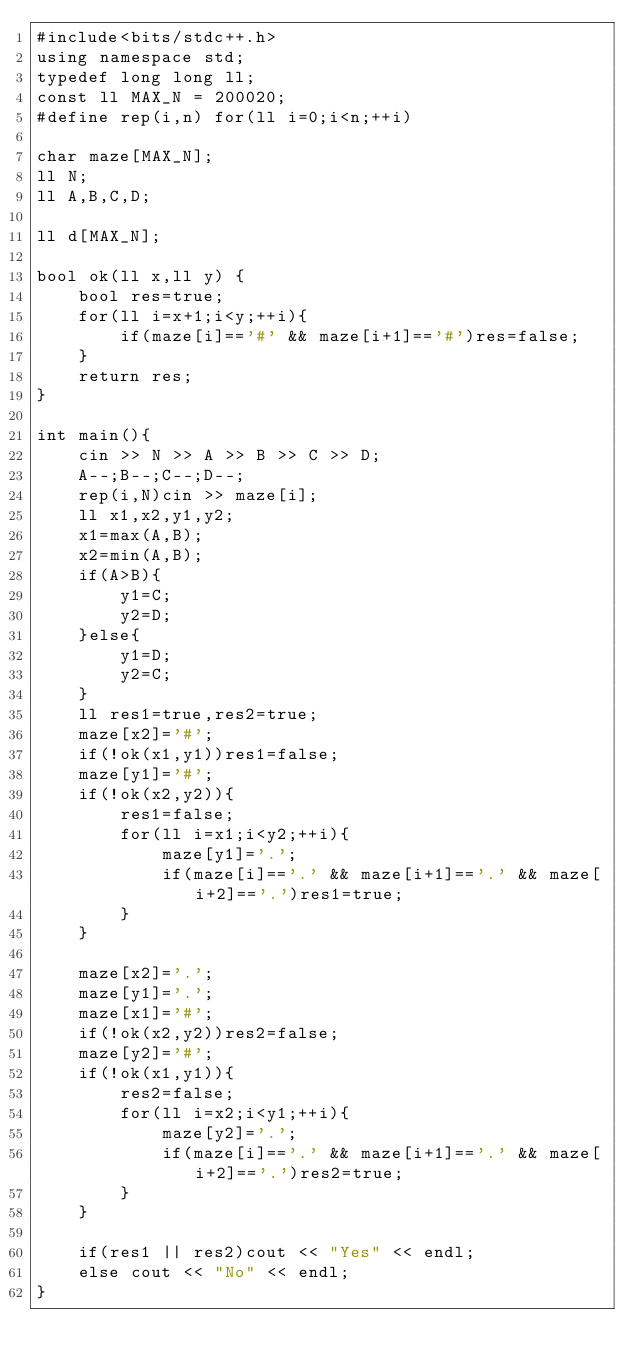<code> <loc_0><loc_0><loc_500><loc_500><_C++_>#include<bits/stdc++.h>
using namespace std;
typedef long long ll;
const ll MAX_N = 200020;
#define rep(i,n) for(ll i=0;i<n;++i)

char maze[MAX_N];
ll N;
ll A,B,C,D;

ll d[MAX_N];

bool ok(ll x,ll y) {
    bool res=true;
    for(ll i=x+1;i<y;++i){
        if(maze[i]=='#' && maze[i+1]=='#')res=false;
    }
    return res;
}

int main(){
    cin >> N >> A >> B >> C >> D;
    A--;B--;C--;D--;
    rep(i,N)cin >> maze[i];
    ll x1,x2,y1,y2;
    x1=max(A,B);
    x2=min(A,B);
    if(A>B){
        y1=C;
        y2=D;
    }else{
        y1=D;
        y2=C;
    }
    ll res1=true,res2=true;
    maze[x2]='#';
    if(!ok(x1,y1))res1=false;
    maze[y1]='#';
    if(!ok(x2,y2)){
        res1=false;
        for(ll i=x1;i<y2;++i){
            maze[y1]='.';
            if(maze[i]=='.' && maze[i+1]=='.' && maze[i+2]=='.')res1=true;
        }
    }

    maze[x2]='.';
    maze[y1]='.';
    maze[x1]='#';
    if(!ok(x2,y2))res2=false;
    maze[y2]='#';
    if(!ok(x1,y1)){
        res2=false;
        for(ll i=x2;i<y1;++i){
            maze[y2]='.';
            if(maze[i]=='.' && maze[i+1]=='.' && maze[i+2]=='.')res2=true;
        }
    }

    if(res1 || res2)cout << "Yes" << endl;
    else cout << "No" << endl;
}</code> 